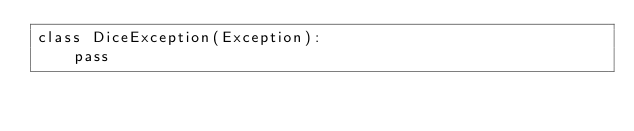<code> <loc_0><loc_0><loc_500><loc_500><_Python_>class DiceException(Exception):
    pass
</code> 